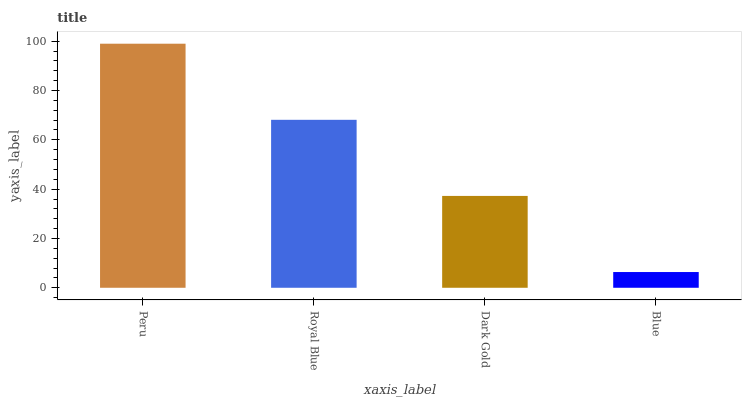Is Blue the minimum?
Answer yes or no. Yes. Is Peru the maximum?
Answer yes or no. Yes. Is Royal Blue the minimum?
Answer yes or no. No. Is Royal Blue the maximum?
Answer yes or no. No. Is Peru greater than Royal Blue?
Answer yes or no. Yes. Is Royal Blue less than Peru?
Answer yes or no. Yes. Is Royal Blue greater than Peru?
Answer yes or no. No. Is Peru less than Royal Blue?
Answer yes or no. No. Is Royal Blue the high median?
Answer yes or no. Yes. Is Dark Gold the low median?
Answer yes or no. Yes. Is Dark Gold the high median?
Answer yes or no. No. Is Peru the low median?
Answer yes or no. No. 